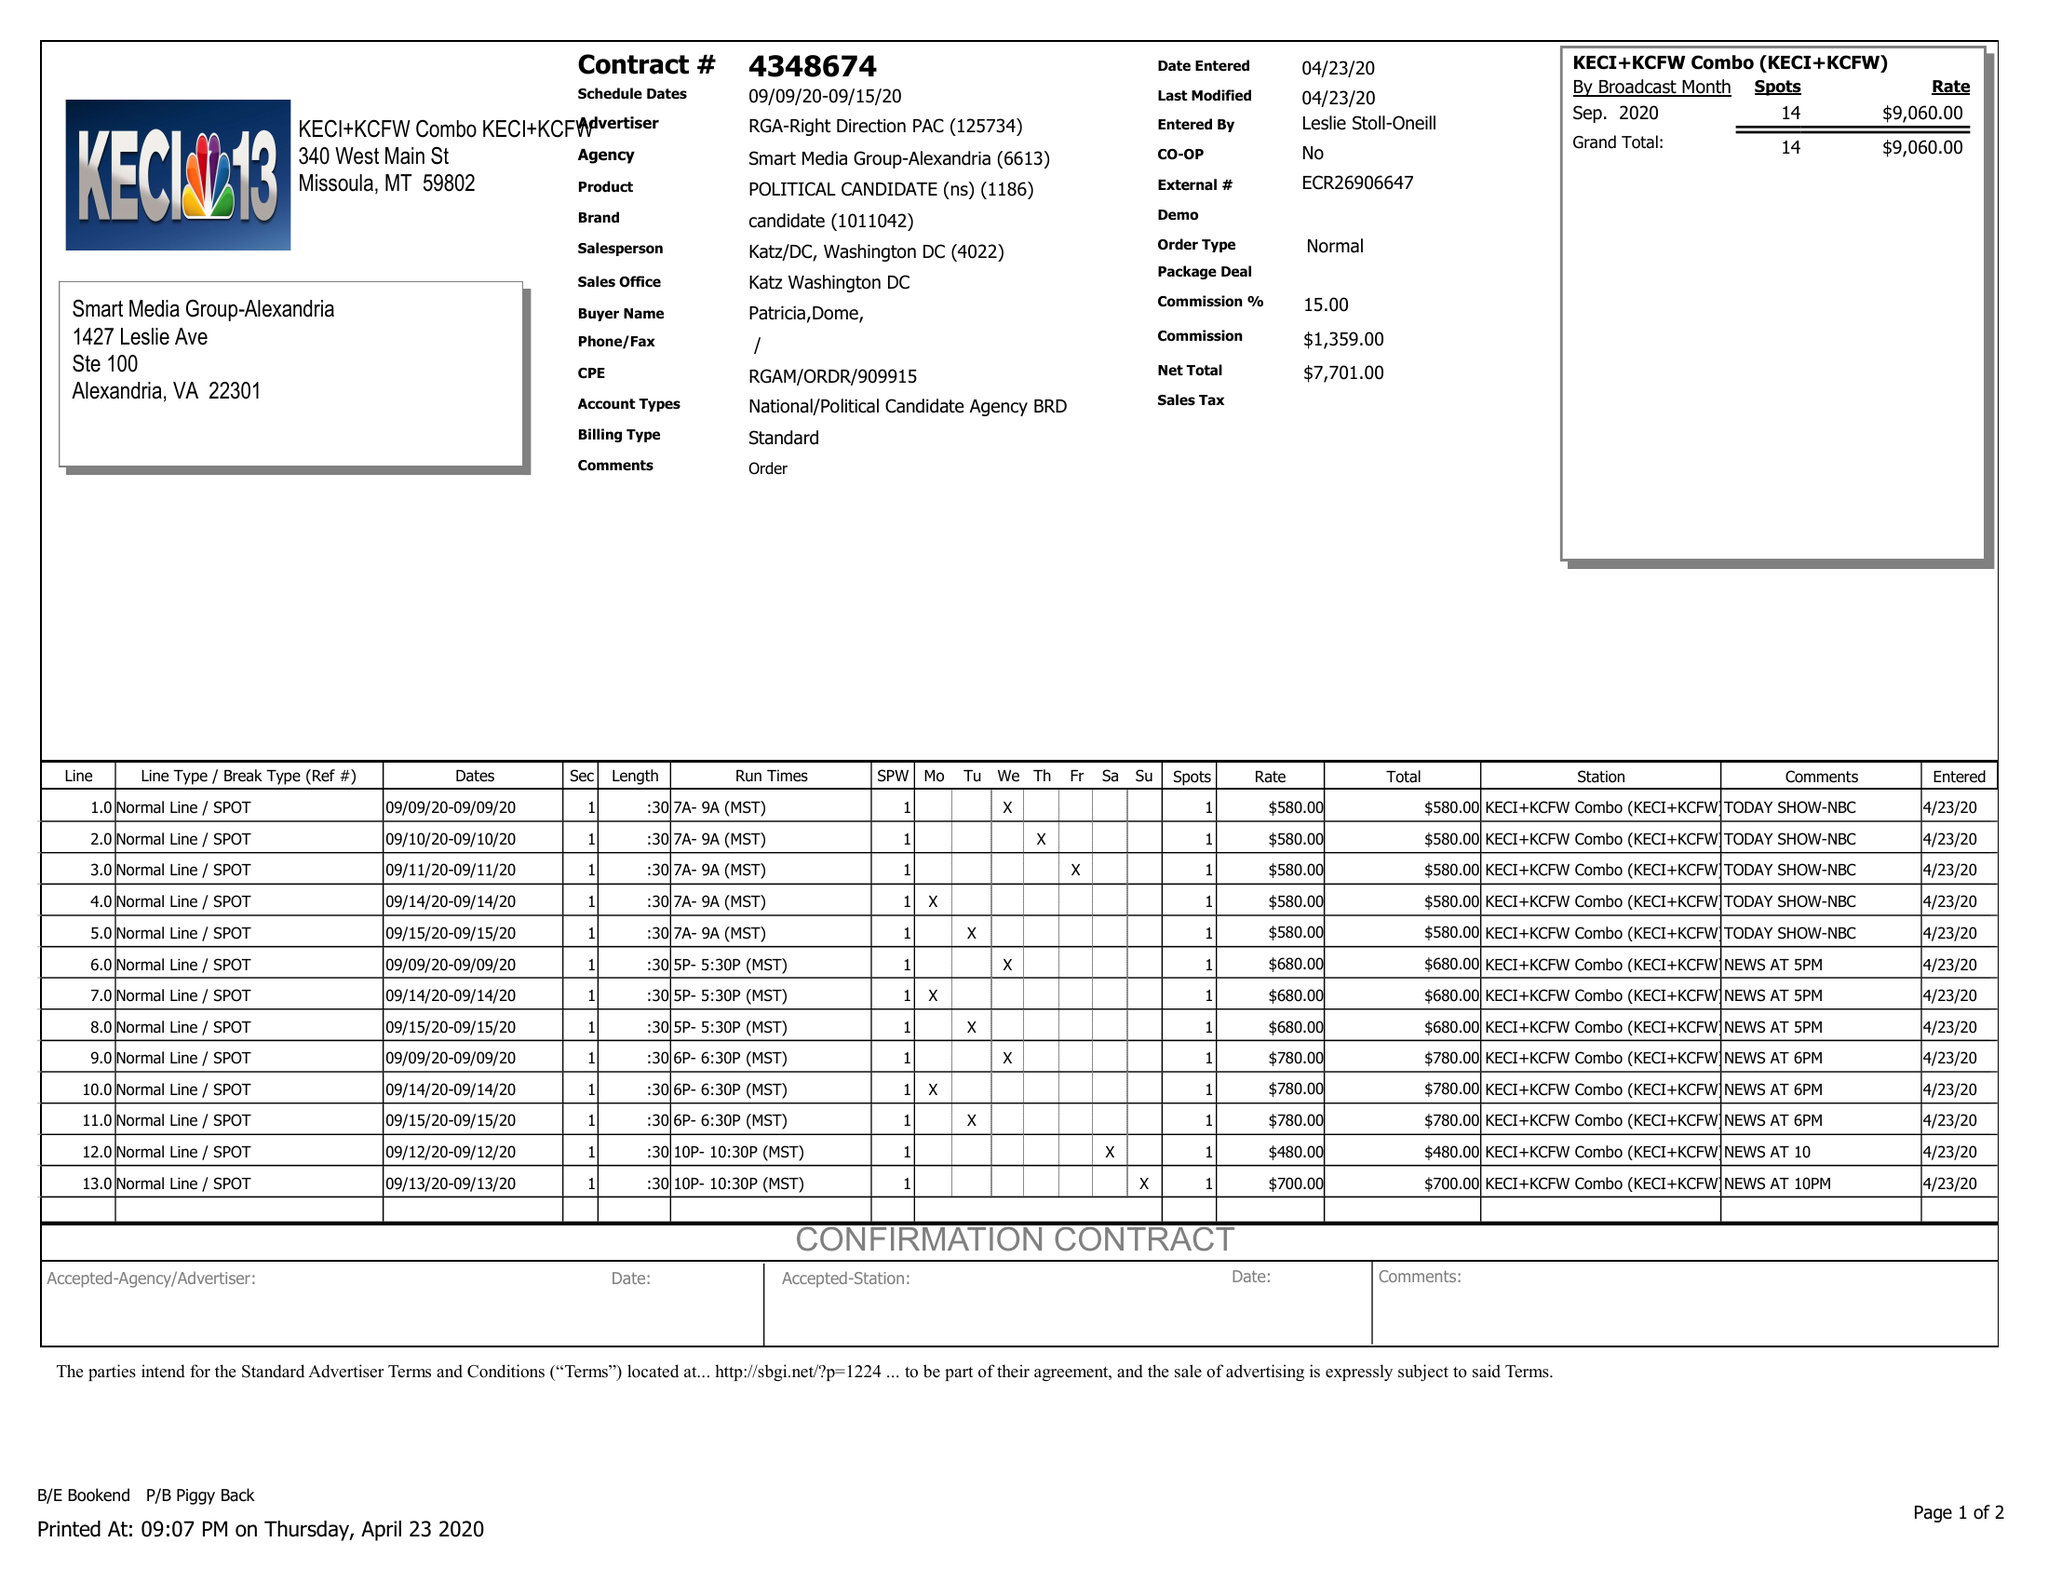What is the value for the flight_from?
Answer the question using a single word or phrase. 09/09/20 